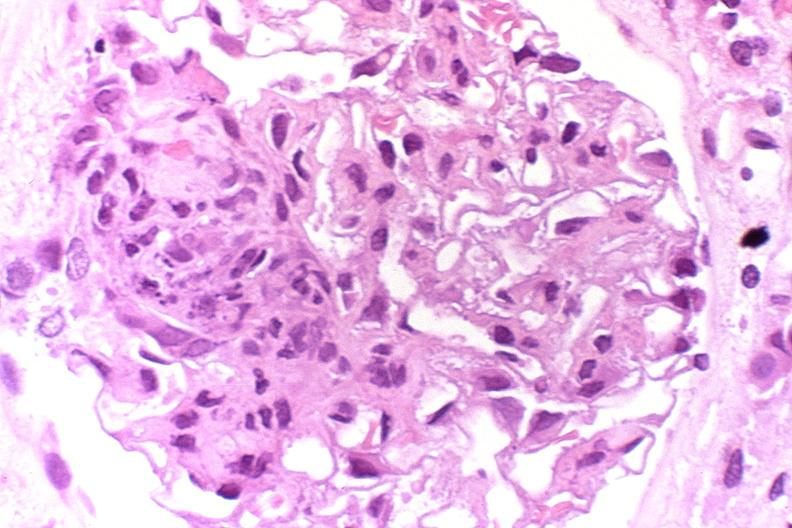what does this image show?
Answer the question using a single word or phrase. Glomerulonephritis 